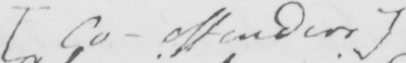Can you read and transcribe this handwriting? [ Co-offenders ] 